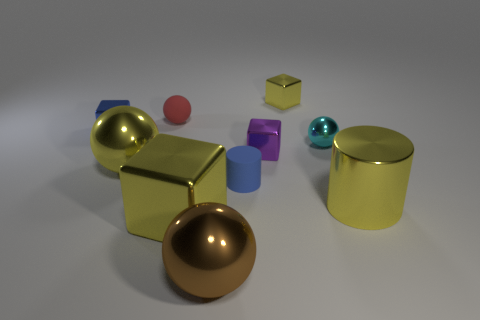Subtract all small blue cubes. How many cubes are left? 3 Subtract all green spheres. How many yellow cubes are left? 2 Subtract all red balls. How many balls are left? 3 Subtract 1 spheres. How many spheres are left? 3 Subtract all cubes. How many objects are left? 6 Subtract all gray balls. Subtract all green cubes. How many balls are left? 4 Subtract 0 blue balls. How many objects are left? 10 Subtract all green metal blocks. Subtract all tiny yellow metal cubes. How many objects are left? 9 Add 7 small blue shiny blocks. How many small blue shiny blocks are left? 8 Add 8 big purple rubber cubes. How many big purple rubber cubes exist? 8 